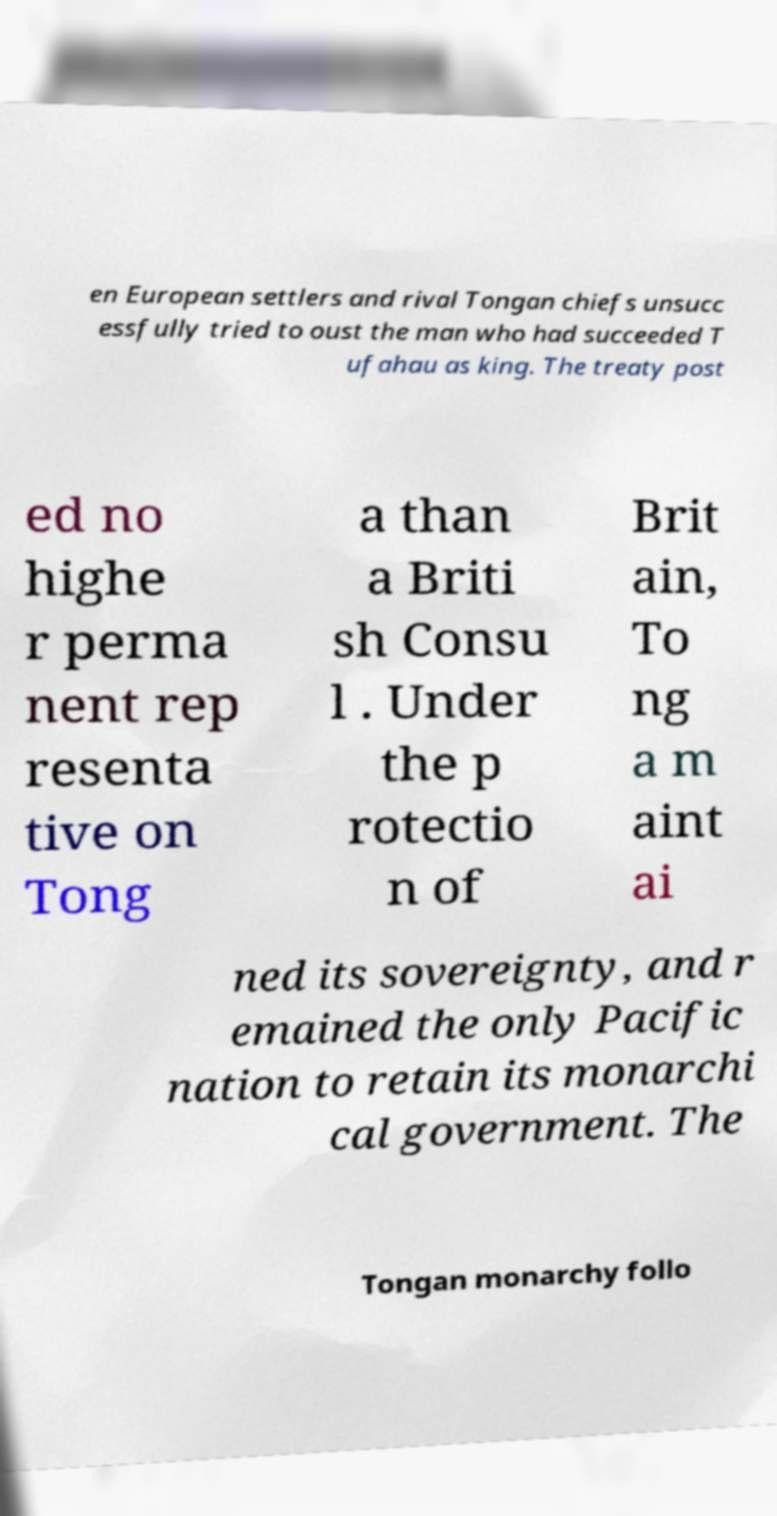What messages or text are displayed in this image? I need them in a readable, typed format. en European settlers and rival Tongan chiefs unsucc essfully tried to oust the man who had succeeded T ufahau as king. The treaty post ed no highe r perma nent rep resenta tive on Tong a than a Briti sh Consu l . Under the p rotectio n of Brit ain, To ng a m aint ai ned its sovereignty, and r emained the only Pacific nation to retain its monarchi cal government. The Tongan monarchy follo 